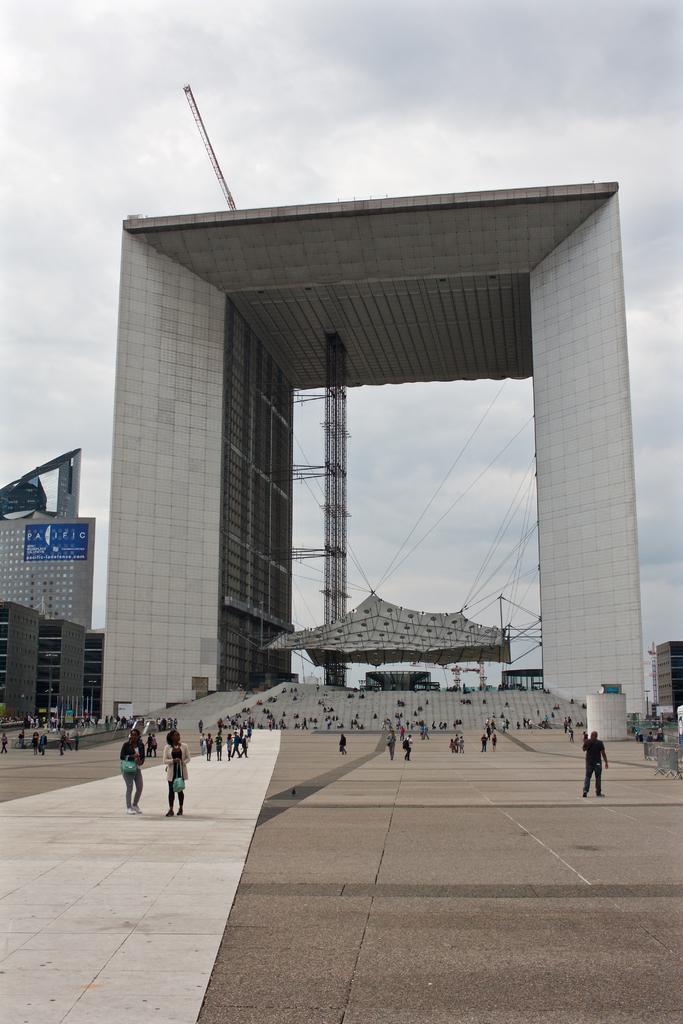In one or two sentences, can you explain what this image depicts? In the picture I can see people walking on the road, we can see the tents tied to the ropes, buildings and the sky with clouds in the background. 